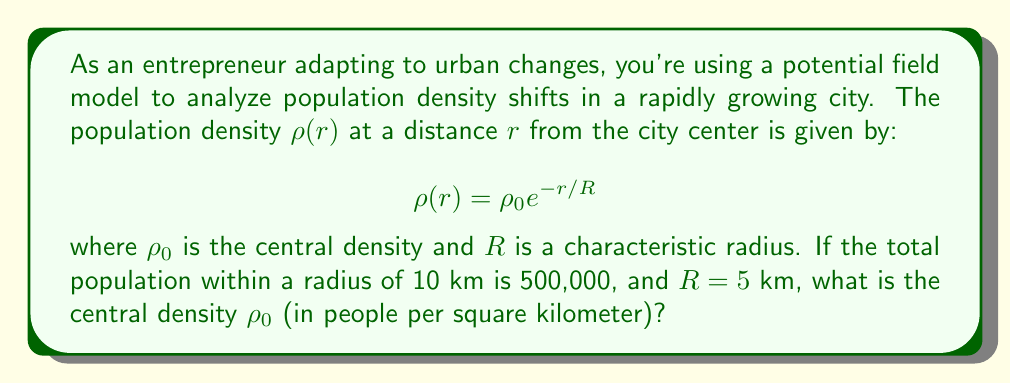Provide a solution to this math problem. Let's approach this step-by-step:

1) The total population $P$ within a radius $r$ is given by the integral:

   $$P = 2\pi \int_0^r \rho(x) x dx$$

2) Substituting our density function:

   $$P = 2\pi \rho_0 \int_0^r e^{-x/R} x dx$$

3) To solve this integral, we use the substitution $u = x/R$, $dx = R du$:

   $$P = 2\pi \rho_0 R^2 \int_0^{r/R} e^{-u} u du$$

4) This integral evaluates to:

   $$P = 2\pi \rho_0 R^2 [1 - (1 + r/R)e^{-r/R}]$$

5) Now, we can plug in our known values: $P = 500,000$, $r = 10$ km, $R = 5$ km:

   $$500,000 = 2\pi \rho_0 (5\text{ km})^2 [1 - (1 + 10/5)e^{-10/5}]$$

6) Simplify:

   $$500,000 = 50\pi \rho_0 [1 - 3e^{-2}]$$

7) Solve for $\rho_0$:

   $$\rho_0 = \frac{500,000}{50\pi [1 - 3e^{-2}]} \approx 3,183.1$$

Therefore, the central density is approximately 3,183 people per square kilometer.
Answer: 3,183 people/km² 